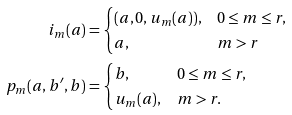Convert formula to latex. <formula><loc_0><loc_0><loc_500><loc_500>i _ { m } ( a ) & = \begin{cases} ( a , 0 , u _ { m } ( a ) ) , & 0 \leq m \leq r , \\ a , & m > r \end{cases} \quad \\ p _ { m } ( a , b ^ { \prime } , b ) & = \begin{cases} b , & 0 \leq m \leq r , \\ u _ { m } ( a ) , & m > r . \end{cases}</formula> 